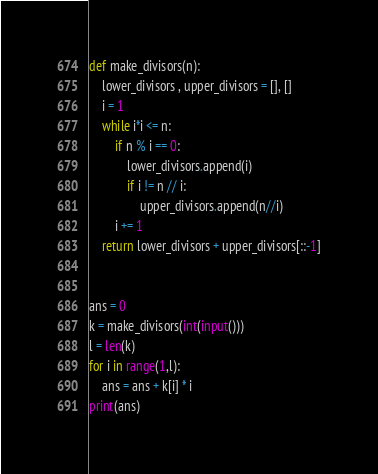<code> <loc_0><loc_0><loc_500><loc_500><_Python_>def make_divisors(n):
    lower_divisors , upper_divisors = [], []
    i = 1
    while i*i <= n:
        if n % i == 0:
            lower_divisors.append(i)
            if i != n // i:
                upper_divisors.append(n//i)
        i += 1
    return lower_divisors + upper_divisors[::-1]


ans = 0
k = make_divisors(int(input()))
l = len(k)
for i in range(1,l):
    ans = ans + k[i] * i 
print(ans)</code> 